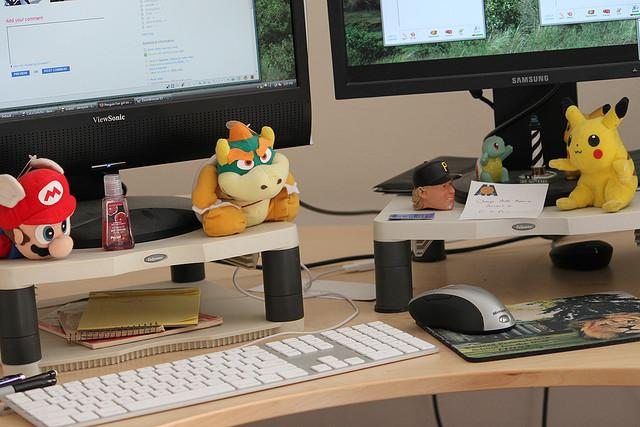What video game does the user of this office space like?

Choices:
A) none
B) super mario
C) pac man
D) what's app super mario 